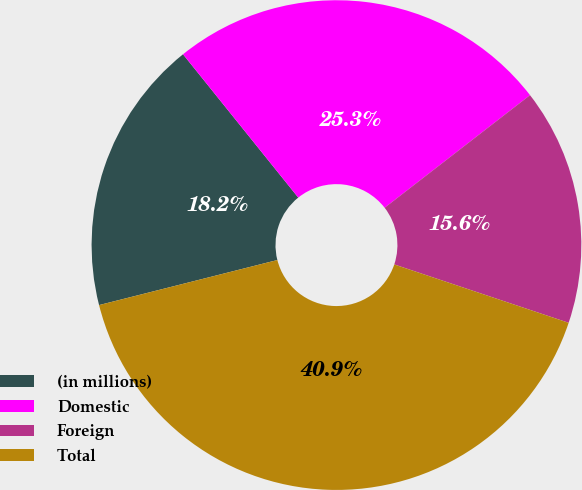<chart> <loc_0><loc_0><loc_500><loc_500><pie_chart><fcel>(in millions)<fcel>Domestic<fcel>Foreign<fcel>Total<nl><fcel>18.16%<fcel>25.29%<fcel>15.63%<fcel>40.92%<nl></chart> 